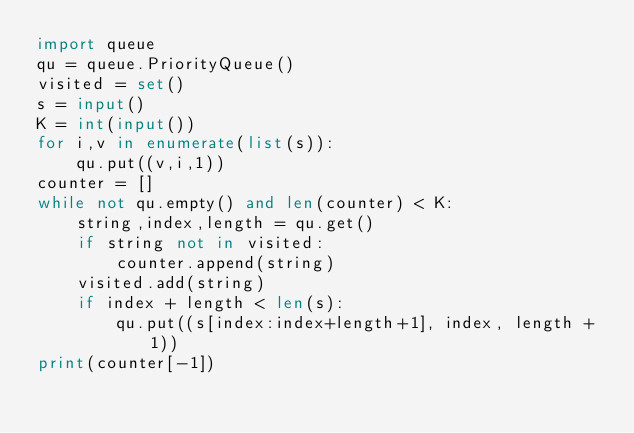Convert code to text. <code><loc_0><loc_0><loc_500><loc_500><_Python_>import queue
qu = queue.PriorityQueue()
visited = set()
s = input()
K = int(input())
for i,v in enumerate(list(s)):
    qu.put((v,i,1))
counter = []
while not qu.empty() and len(counter) < K:
    string,index,length = qu.get()
    if string not in visited:
        counter.append(string)
    visited.add(string)
    if index + length < len(s):
        qu.put((s[index:index+length+1], index, length + 1))
print(counter[-1])

</code> 